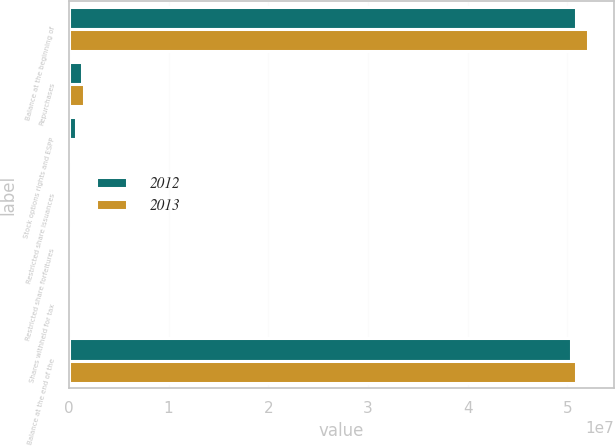Convert chart to OTSL. <chart><loc_0><loc_0><loc_500><loc_500><stacked_bar_chart><ecel><fcel>Balance at the beginning of<fcel>Repurchases<fcel>Stock options rights and ESPP<fcel>Restricted share issuances<fcel>Restricted share forfeitures<fcel>Shares withheld for tax<fcel>Balance at the end of the<nl><fcel>2012<fcel>5.09083e+07<fcel>1.35686e+06<fcel>739148<fcel>241851<fcel>165610<fcel>17249<fcel>5.03495e+07<nl><fcel>2013<fcel>5.20952e+07<fcel>1.47386e+06<fcel>246625<fcel>242238<fcel>130119<fcel>71780<fcel>5.09083e+07<nl></chart> 